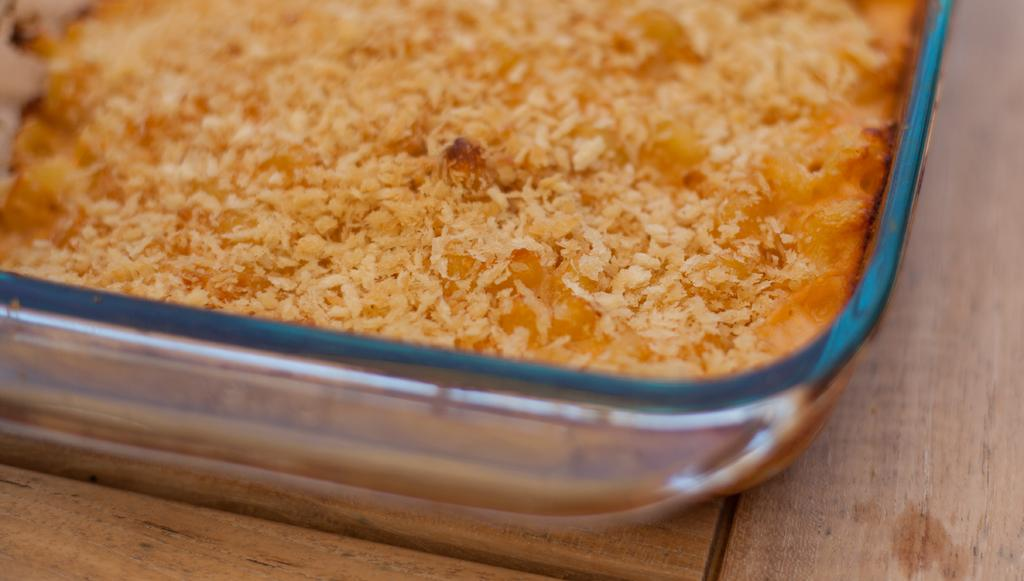What is in the bowl that is visible in the image? There is a bowl containing food in the image. Where is the bowl located in the image? The bowl is placed on a table. What type of beam can be seen supporting the table in the image? There is no beam visible in the image, and the table's support structure is not mentioned in the provided facts. Can you tell me how many aunts are present in the image? There is no mention of an aunt or any people in the image, so it is impossible to determine the number of aunts present. 